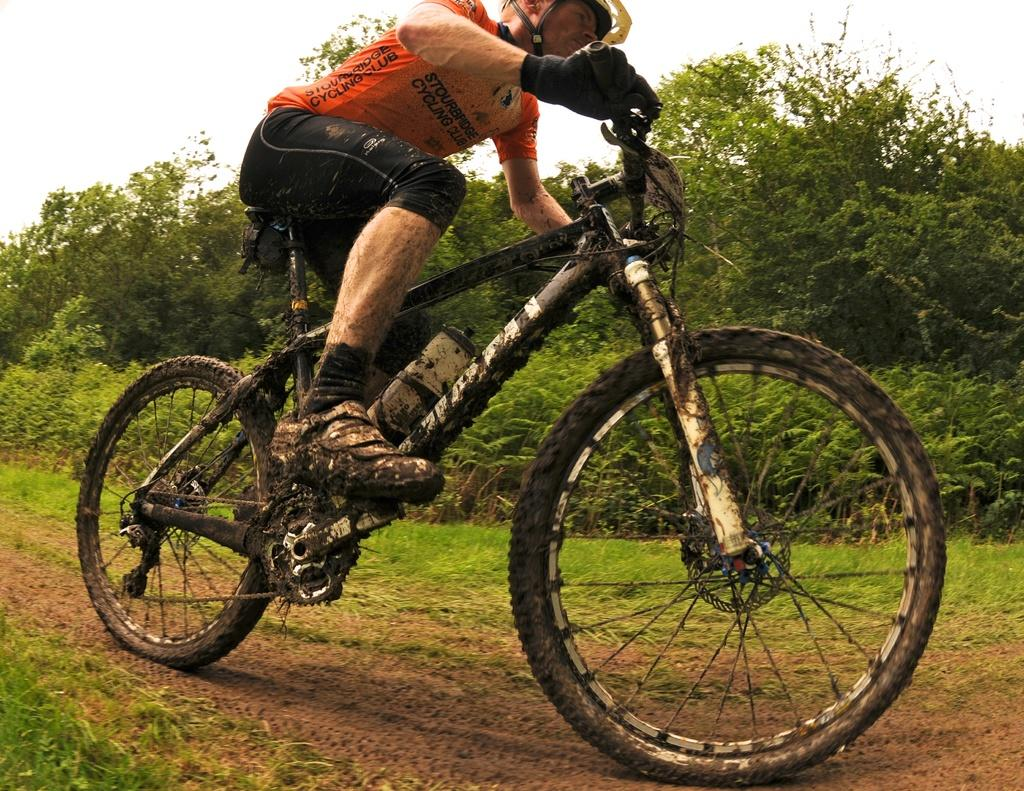<image>
Render a clear and concise summary of the photo. A cyclist wearing an orange jersey that says Stourbridge Cycling Club rides down a dirt road 